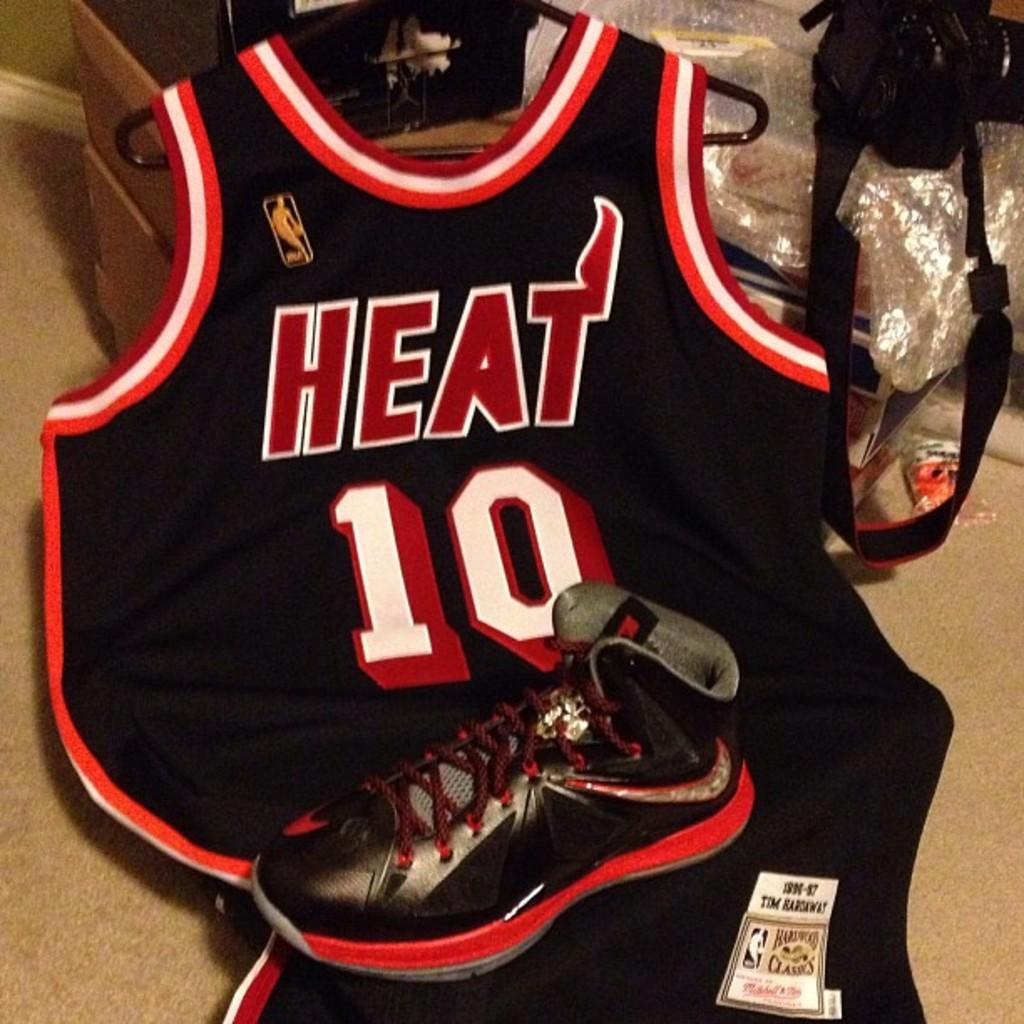<image>
Write a terse but informative summary of the picture. A player wears Number Ten in the Heat basketball team. 